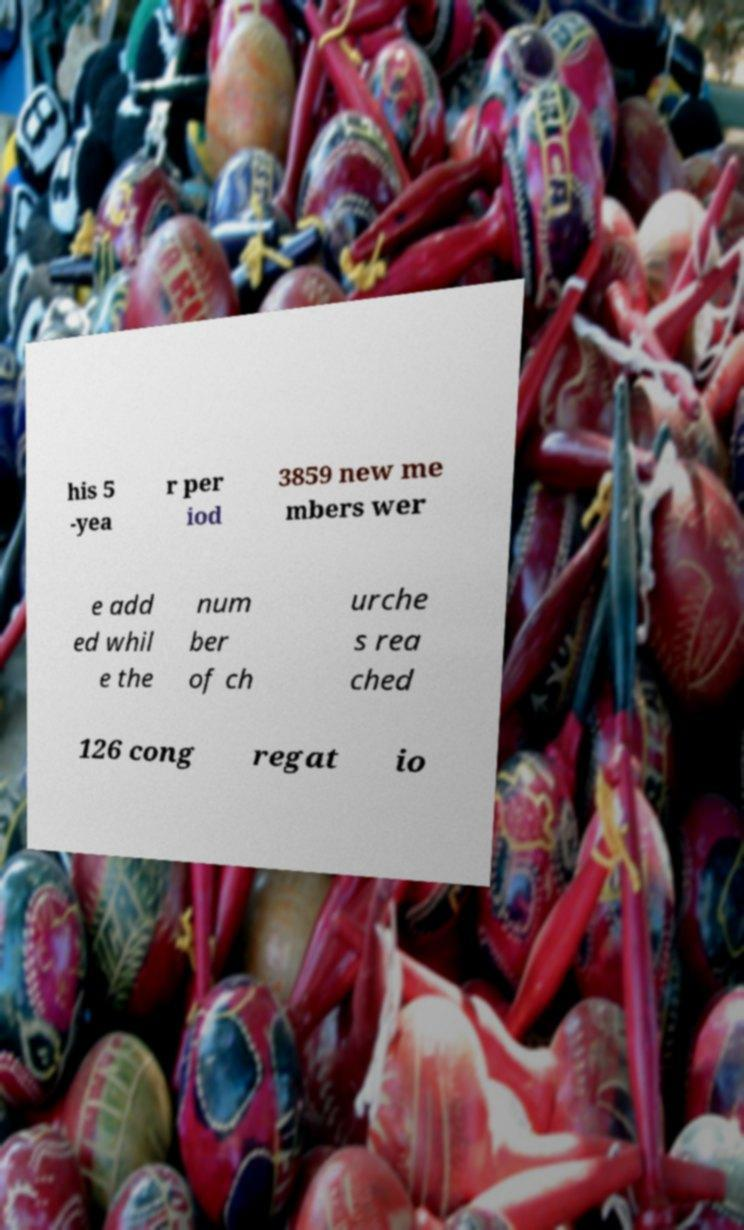For documentation purposes, I need the text within this image transcribed. Could you provide that? his 5 -yea r per iod 3859 new me mbers wer e add ed whil e the num ber of ch urche s rea ched 126 cong regat io 